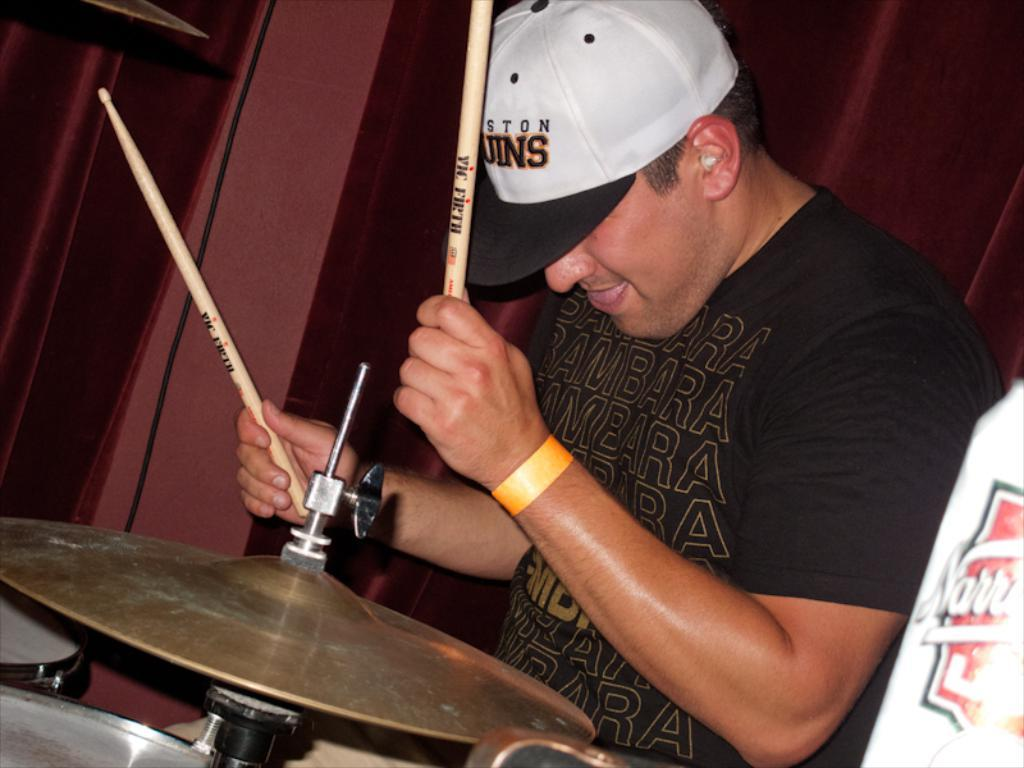<image>
Present a compact description of the photo's key features. A man in a Boston Bruins caps playing drums. 